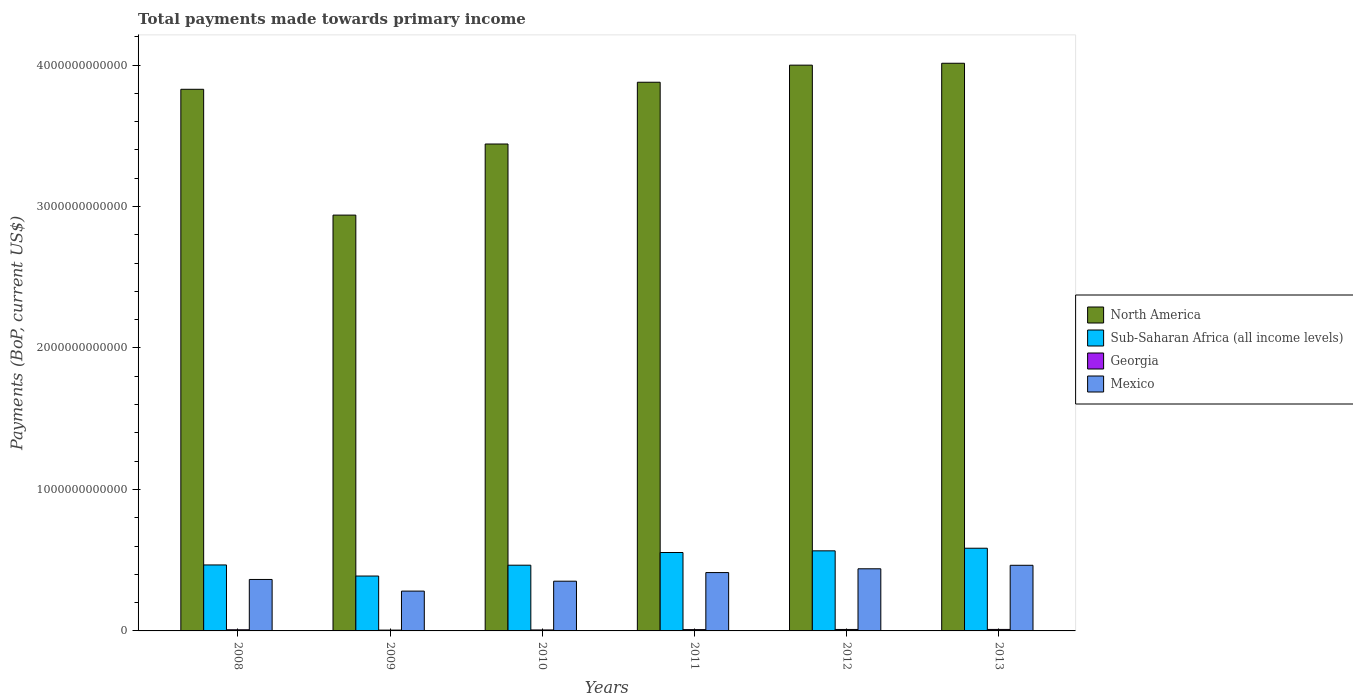How many different coloured bars are there?
Give a very brief answer. 4. Are the number of bars on each tick of the X-axis equal?
Keep it short and to the point. Yes. What is the label of the 4th group of bars from the left?
Make the answer very short. 2011. In how many cases, is the number of bars for a given year not equal to the number of legend labels?
Offer a very short reply. 0. What is the total payments made towards primary income in Mexico in 2013?
Give a very brief answer. 4.64e+11. Across all years, what is the maximum total payments made towards primary income in Mexico?
Your answer should be compact. 4.64e+11. Across all years, what is the minimum total payments made towards primary income in Georgia?
Offer a terse response. 5.78e+09. What is the total total payments made towards primary income in Georgia in the graph?
Your response must be concise. 5.08e+1. What is the difference between the total payments made towards primary income in Georgia in 2010 and that in 2013?
Your answer should be compact. -3.60e+09. What is the difference between the total payments made towards primary income in Georgia in 2011 and the total payments made towards primary income in North America in 2012?
Provide a short and direct response. -3.99e+12. What is the average total payments made towards primary income in Mexico per year?
Keep it short and to the point. 3.85e+11. In the year 2008, what is the difference between the total payments made towards primary income in Sub-Saharan Africa (all income levels) and total payments made towards primary income in Georgia?
Keep it short and to the point. 4.58e+11. In how many years, is the total payments made towards primary income in Sub-Saharan Africa (all income levels) greater than 1200000000000 US$?
Your answer should be compact. 0. What is the ratio of the total payments made towards primary income in North America in 2009 to that in 2012?
Your response must be concise. 0.73. What is the difference between the highest and the second highest total payments made towards primary income in Georgia?
Make the answer very short. 1.32e+08. What is the difference between the highest and the lowest total payments made towards primary income in Georgia?
Your response must be concise. 4.71e+09. Is the sum of the total payments made towards primary income in Sub-Saharan Africa (all income levels) in 2011 and 2013 greater than the maximum total payments made towards primary income in Georgia across all years?
Your response must be concise. Yes. What does the 1st bar from the left in 2013 represents?
Provide a succinct answer. North America. What does the 2nd bar from the right in 2009 represents?
Give a very brief answer. Georgia. How many bars are there?
Offer a terse response. 24. Are all the bars in the graph horizontal?
Give a very brief answer. No. How many years are there in the graph?
Keep it short and to the point. 6. What is the difference between two consecutive major ticks on the Y-axis?
Offer a very short reply. 1.00e+12. Are the values on the major ticks of Y-axis written in scientific E-notation?
Give a very brief answer. No. Where does the legend appear in the graph?
Provide a short and direct response. Center right. How many legend labels are there?
Offer a very short reply. 4. How are the legend labels stacked?
Offer a very short reply. Vertical. What is the title of the graph?
Your answer should be compact. Total payments made towards primary income. What is the label or title of the Y-axis?
Give a very brief answer. Payments (BoP, current US$). What is the Payments (BoP, current US$) of North America in 2008?
Ensure brevity in your answer.  3.83e+12. What is the Payments (BoP, current US$) of Sub-Saharan Africa (all income levels) in 2008?
Your response must be concise. 4.66e+11. What is the Payments (BoP, current US$) of Georgia in 2008?
Provide a short and direct response. 8.11e+09. What is the Payments (BoP, current US$) of Mexico in 2008?
Provide a short and direct response. 3.64e+11. What is the Payments (BoP, current US$) of North America in 2009?
Offer a very short reply. 2.94e+12. What is the Payments (BoP, current US$) of Sub-Saharan Africa (all income levels) in 2009?
Your answer should be compact. 3.88e+11. What is the Payments (BoP, current US$) of Georgia in 2009?
Offer a terse response. 5.78e+09. What is the Payments (BoP, current US$) of Mexico in 2009?
Offer a terse response. 2.82e+11. What is the Payments (BoP, current US$) in North America in 2010?
Your answer should be very brief. 3.44e+12. What is the Payments (BoP, current US$) in Sub-Saharan Africa (all income levels) in 2010?
Your answer should be very brief. 4.65e+11. What is the Payments (BoP, current US$) in Georgia in 2010?
Ensure brevity in your answer.  6.89e+09. What is the Payments (BoP, current US$) of Mexico in 2010?
Offer a very short reply. 3.51e+11. What is the Payments (BoP, current US$) in North America in 2011?
Your response must be concise. 3.88e+12. What is the Payments (BoP, current US$) of Sub-Saharan Africa (all income levels) in 2011?
Give a very brief answer. 5.54e+11. What is the Payments (BoP, current US$) in Georgia in 2011?
Ensure brevity in your answer.  9.17e+09. What is the Payments (BoP, current US$) in Mexico in 2011?
Provide a succinct answer. 4.12e+11. What is the Payments (BoP, current US$) in North America in 2012?
Give a very brief answer. 4.00e+12. What is the Payments (BoP, current US$) of Sub-Saharan Africa (all income levels) in 2012?
Ensure brevity in your answer.  5.66e+11. What is the Payments (BoP, current US$) of Georgia in 2012?
Offer a terse response. 1.04e+1. What is the Payments (BoP, current US$) of Mexico in 2012?
Your response must be concise. 4.39e+11. What is the Payments (BoP, current US$) in North America in 2013?
Your answer should be compact. 4.01e+12. What is the Payments (BoP, current US$) of Sub-Saharan Africa (all income levels) in 2013?
Provide a short and direct response. 5.84e+11. What is the Payments (BoP, current US$) of Georgia in 2013?
Provide a succinct answer. 1.05e+1. What is the Payments (BoP, current US$) of Mexico in 2013?
Your response must be concise. 4.64e+11. Across all years, what is the maximum Payments (BoP, current US$) of North America?
Keep it short and to the point. 4.01e+12. Across all years, what is the maximum Payments (BoP, current US$) of Sub-Saharan Africa (all income levels)?
Provide a short and direct response. 5.84e+11. Across all years, what is the maximum Payments (BoP, current US$) in Georgia?
Give a very brief answer. 1.05e+1. Across all years, what is the maximum Payments (BoP, current US$) in Mexico?
Provide a succinct answer. 4.64e+11. Across all years, what is the minimum Payments (BoP, current US$) in North America?
Your answer should be very brief. 2.94e+12. Across all years, what is the minimum Payments (BoP, current US$) in Sub-Saharan Africa (all income levels)?
Offer a terse response. 3.88e+11. Across all years, what is the minimum Payments (BoP, current US$) of Georgia?
Offer a very short reply. 5.78e+09. Across all years, what is the minimum Payments (BoP, current US$) of Mexico?
Your answer should be compact. 2.82e+11. What is the total Payments (BoP, current US$) in North America in the graph?
Keep it short and to the point. 2.21e+13. What is the total Payments (BoP, current US$) of Sub-Saharan Africa (all income levels) in the graph?
Provide a succinct answer. 3.02e+12. What is the total Payments (BoP, current US$) in Georgia in the graph?
Make the answer very short. 5.08e+1. What is the total Payments (BoP, current US$) in Mexico in the graph?
Make the answer very short. 2.31e+12. What is the difference between the Payments (BoP, current US$) of North America in 2008 and that in 2009?
Your answer should be compact. 8.89e+11. What is the difference between the Payments (BoP, current US$) in Sub-Saharan Africa (all income levels) in 2008 and that in 2009?
Keep it short and to the point. 7.84e+1. What is the difference between the Payments (BoP, current US$) in Georgia in 2008 and that in 2009?
Make the answer very short. 2.34e+09. What is the difference between the Payments (BoP, current US$) of Mexico in 2008 and that in 2009?
Keep it short and to the point. 8.22e+1. What is the difference between the Payments (BoP, current US$) of North America in 2008 and that in 2010?
Offer a very short reply. 3.87e+11. What is the difference between the Payments (BoP, current US$) of Sub-Saharan Africa (all income levels) in 2008 and that in 2010?
Your answer should be compact. 1.75e+09. What is the difference between the Payments (BoP, current US$) of Georgia in 2008 and that in 2010?
Provide a succinct answer. 1.23e+09. What is the difference between the Payments (BoP, current US$) of Mexico in 2008 and that in 2010?
Ensure brevity in your answer.  1.23e+1. What is the difference between the Payments (BoP, current US$) of North America in 2008 and that in 2011?
Make the answer very short. -4.97e+1. What is the difference between the Payments (BoP, current US$) of Sub-Saharan Africa (all income levels) in 2008 and that in 2011?
Offer a very short reply. -8.79e+1. What is the difference between the Payments (BoP, current US$) in Georgia in 2008 and that in 2011?
Keep it short and to the point. -1.05e+09. What is the difference between the Payments (BoP, current US$) in Mexico in 2008 and that in 2011?
Provide a short and direct response. -4.87e+1. What is the difference between the Payments (BoP, current US$) in North America in 2008 and that in 2012?
Keep it short and to the point. -1.71e+11. What is the difference between the Payments (BoP, current US$) in Sub-Saharan Africa (all income levels) in 2008 and that in 2012?
Your answer should be compact. -9.98e+1. What is the difference between the Payments (BoP, current US$) of Georgia in 2008 and that in 2012?
Provide a short and direct response. -2.24e+09. What is the difference between the Payments (BoP, current US$) in Mexico in 2008 and that in 2012?
Provide a short and direct response. -7.54e+1. What is the difference between the Payments (BoP, current US$) in North America in 2008 and that in 2013?
Offer a very short reply. -1.84e+11. What is the difference between the Payments (BoP, current US$) of Sub-Saharan Africa (all income levels) in 2008 and that in 2013?
Your answer should be compact. -1.18e+11. What is the difference between the Payments (BoP, current US$) of Georgia in 2008 and that in 2013?
Your answer should be compact. -2.37e+09. What is the difference between the Payments (BoP, current US$) in Mexico in 2008 and that in 2013?
Make the answer very short. -1.00e+11. What is the difference between the Payments (BoP, current US$) in North America in 2009 and that in 2010?
Make the answer very short. -5.02e+11. What is the difference between the Payments (BoP, current US$) of Sub-Saharan Africa (all income levels) in 2009 and that in 2010?
Your answer should be compact. -7.67e+1. What is the difference between the Payments (BoP, current US$) of Georgia in 2009 and that in 2010?
Offer a terse response. -1.11e+09. What is the difference between the Payments (BoP, current US$) of Mexico in 2009 and that in 2010?
Make the answer very short. -7.00e+1. What is the difference between the Payments (BoP, current US$) in North America in 2009 and that in 2011?
Your response must be concise. -9.39e+11. What is the difference between the Payments (BoP, current US$) in Sub-Saharan Africa (all income levels) in 2009 and that in 2011?
Offer a terse response. -1.66e+11. What is the difference between the Payments (BoP, current US$) of Georgia in 2009 and that in 2011?
Offer a very short reply. -3.39e+09. What is the difference between the Payments (BoP, current US$) of Mexico in 2009 and that in 2011?
Your answer should be compact. -1.31e+11. What is the difference between the Payments (BoP, current US$) in North America in 2009 and that in 2012?
Make the answer very short. -1.06e+12. What is the difference between the Payments (BoP, current US$) of Sub-Saharan Africa (all income levels) in 2009 and that in 2012?
Your answer should be compact. -1.78e+11. What is the difference between the Payments (BoP, current US$) of Georgia in 2009 and that in 2012?
Offer a very short reply. -4.58e+09. What is the difference between the Payments (BoP, current US$) of Mexico in 2009 and that in 2012?
Offer a terse response. -1.58e+11. What is the difference between the Payments (BoP, current US$) of North America in 2009 and that in 2013?
Provide a succinct answer. -1.07e+12. What is the difference between the Payments (BoP, current US$) in Sub-Saharan Africa (all income levels) in 2009 and that in 2013?
Provide a succinct answer. -1.97e+11. What is the difference between the Payments (BoP, current US$) in Georgia in 2009 and that in 2013?
Your answer should be compact. -4.71e+09. What is the difference between the Payments (BoP, current US$) of Mexico in 2009 and that in 2013?
Keep it short and to the point. -1.82e+11. What is the difference between the Payments (BoP, current US$) of North America in 2010 and that in 2011?
Make the answer very short. -4.37e+11. What is the difference between the Payments (BoP, current US$) in Sub-Saharan Africa (all income levels) in 2010 and that in 2011?
Your answer should be very brief. -8.97e+1. What is the difference between the Payments (BoP, current US$) of Georgia in 2010 and that in 2011?
Your response must be concise. -2.28e+09. What is the difference between the Payments (BoP, current US$) in Mexico in 2010 and that in 2011?
Ensure brevity in your answer.  -6.10e+1. What is the difference between the Payments (BoP, current US$) of North America in 2010 and that in 2012?
Your answer should be compact. -5.57e+11. What is the difference between the Payments (BoP, current US$) in Sub-Saharan Africa (all income levels) in 2010 and that in 2012?
Make the answer very short. -1.02e+11. What is the difference between the Payments (BoP, current US$) in Georgia in 2010 and that in 2012?
Give a very brief answer. -3.47e+09. What is the difference between the Payments (BoP, current US$) of Mexico in 2010 and that in 2012?
Your answer should be very brief. -8.77e+1. What is the difference between the Payments (BoP, current US$) of North America in 2010 and that in 2013?
Ensure brevity in your answer.  -5.71e+11. What is the difference between the Payments (BoP, current US$) of Sub-Saharan Africa (all income levels) in 2010 and that in 2013?
Your answer should be very brief. -1.20e+11. What is the difference between the Payments (BoP, current US$) in Georgia in 2010 and that in 2013?
Your response must be concise. -3.60e+09. What is the difference between the Payments (BoP, current US$) in Mexico in 2010 and that in 2013?
Your answer should be very brief. -1.12e+11. What is the difference between the Payments (BoP, current US$) in North America in 2011 and that in 2012?
Your answer should be compact. -1.21e+11. What is the difference between the Payments (BoP, current US$) of Sub-Saharan Africa (all income levels) in 2011 and that in 2012?
Your response must be concise. -1.19e+1. What is the difference between the Payments (BoP, current US$) in Georgia in 2011 and that in 2012?
Provide a succinct answer. -1.19e+09. What is the difference between the Payments (BoP, current US$) in Mexico in 2011 and that in 2012?
Give a very brief answer. -2.67e+1. What is the difference between the Payments (BoP, current US$) in North America in 2011 and that in 2013?
Give a very brief answer. -1.34e+11. What is the difference between the Payments (BoP, current US$) in Sub-Saharan Africa (all income levels) in 2011 and that in 2013?
Make the answer very short. -3.03e+1. What is the difference between the Payments (BoP, current US$) of Georgia in 2011 and that in 2013?
Your response must be concise. -1.32e+09. What is the difference between the Payments (BoP, current US$) in Mexico in 2011 and that in 2013?
Your response must be concise. -5.14e+1. What is the difference between the Payments (BoP, current US$) of North America in 2012 and that in 2013?
Your answer should be compact. -1.33e+1. What is the difference between the Payments (BoP, current US$) in Sub-Saharan Africa (all income levels) in 2012 and that in 2013?
Your answer should be very brief. -1.84e+1. What is the difference between the Payments (BoP, current US$) of Georgia in 2012 and that in 2013?
Keep it short and to the point. -1.32e+08. What is the difference between the Payments (BoP, current US$) in Mexico in 2012 and that in 2013?
Your answer should be very brief. -2.47e+1. What is the difference between the Payments (BoP, current US$) of North America in 2008 and the Payments (BoP, current US$) of Sub-Saharan Africa (all income levels) in 2009?
Make the answer very short. 3.44e+12. What is the difference between the Payments (BoP, current US$) in North America in 2008 and the Payments (BoP, current US$) in Georgia in 2009?
Provide a succinct answer. 3.82e+12. What is the difference between the Payments (BoP, current US$) of North America in 2008 and the Payments (BoP, current US$) of Mexico in 2009?
Offer a very short reply. 3.55e+12. What is the difference between the Payments (BoP, current US$) of Sub-Saharan Africa (all income levels) in 2008 and the Payments (BoP, current US$) of Georgia in 2009?
Your answer should be compact. 4.61e+11. What is the difference between the Payments (BoP, current US$) of Sub-Saharan Africa (all income levels) in 2008 and the Payments (BoP, current US$) of Mexico in 2009?
Provide a succinct answer. 1.85e+11. What is the difference between the Payments (BoP, current US$) in Georgia in 2008 and the Payments (BoP, current US$) in Mexico in 2009?
Offer a terse response. -2.73e+11. What is the difference between the Payments (BoP, current US$) of North America in 2008 and the Payments (BoP, current US$) of Sub-Saharan Africa (all income levels) in 2010?
Offer a very short reply. 3.36e+12. What is the difference between the Payments (BoP, current US$) of North America in 2008 and the Payments (BoP, current US$) of Georgia in 2010?
Provide a succinct answer. 3.82e+12. What is the difference between the Payments (BoP, current US$) in North America in 2008 and the Payments (BoP, current US$) in Mexico in 2010?
Offer a terse response. 3.48e+12. What is the difference between the Payments (BoP, current US$) in Sub-Saharan Africa (all income levels) in 2008 and the Payments (BoP, current US$) in Georgia in 2010?
Ensure brevity in your answer.  4.59e+11. What is the difference between the Payments (BoP, current US$) in Sub-Saharan Africa (all income levels) in 2008 and the Payments (BoP, current US$) in Mexico in 2010?
Offer a very short reply. 1.15e+11. What is the difference between the Payments (BoP, current US$) in Georgia in 2008 and the Payments (BoP, current US$) in Mexico in 2010?
Ensure brevity in your answer.  -3.43e+11. What is the difference between the Payments (BoP, current US$) in North America in 2008 and the Payments (BoP, current US$) in Sub-Saharan Africa (all income levels) in 2011?
Your response must be concise. 3.27e+12. What is the difference between the Payments (BoP, current US$) in North America in 2008 and the Payments (BoP, current US$) in Georgia in 2011?
Your response must be concise. 3.82e+12. What is the difference between the Payments (BoP, current US$) in North America in 2008 and the Payments (BoP, current US$) in Mexico in 2011?
Your answer should be compact. 3.42e+12. What is the difference between the Payments (BoP, current US$) in Sub-Saharan Africa (all income levels) in 2008 and the Payments (BoP, current US$) in Georgia in 2011?
Your response must be concise. 4.57e+11. What is the difference between the Payments (BoP, current US$) of Sub-Saharan Africa (all income levels) in 2008 and the Payments (BoP, current US$) of Mexico in 2011?
Provide a succinct answer. 5.39e+1. What is the difference between the Payments (BoP, current US$) in Georgia in 2008 and the Payments (BoP, current US$) in Mexico in 2011?
Give a very brief answer. -4.04e+11. What is the difference between the Payments (BoP, current US$) of North America in 2008 and the Payments (BoP, current US$) of Sub-Saharan Africa (all income levels) in 2012?
Make the answer very short. 3.26e+12. What is the difference between the Payments (BoP, current US$) in North America in 2008 and the Payments (BoP, current US$) in Georgia in 2012?
Your response must be concise. 3.82e+12. What is the difference between the Payments (BoP, current US$) in North America in 2008 and the Payments (BoP, current US$) in Mexico in 2012?
Provide a succinct answer. 3.39e+12. What is the difference between the Payments (BoP, current US$) of Sub-Saharan Africa (all income levels) in 2008 and the Payments (BoP, current US$) of Georgia in 2012?
Give a very brief answer. 4.56e+11. What is the difference between the Payments (BoP, current US$) in Sub-Saharan Africa (all income levels) in 2008 and the Payments (BoP, current US$) in Mexico in 2012?
Keep it short and to the point. 2.71e+1. What is the difference between the Payments (BoP, current US$) of Georgia in 2008 and the Payments (BoP, current US$) of Mexico in 2012?
Provide a succinct answer. -4.31e+11. What is the difference between the Payments (BoP, current US$) in North America in 2008 and the Payments (BoP, current US$) in Sub-Saharan Africa (all income levels) in 2013?
Ensure brevity in your answer.  3.24e+12. What is the difference between the Payments (BoP, current US$) of North America in 2008 and the Payments (BoP, current US$) of Georgia in 2013?
Keep it short and to the point. 3.82e+12. What is the difference between the Payments (BoP, current US$) of North America in 2008 and the Payments (BoP, current US$) of Mexico in 2013?
Provide a short and direct response. 3.36e+12. What is the difference between the Payments (BoP, current US$) in Sub-Saharan Africa (all income levels) in 2008 and the Payments (BoP, current US$) in Georgia in 2013?
Your answer should be compact. 4.56e+11. What is the difference between the Payments (BoP, current US$) of Sub-Saharan Africa (all income levels) in 2008 and the Payments (BoP, current US$) of Mexico in 2013?
Provide a short and direct response. 2.45e+09. What is the difference between the Payments (BoP, current US$) in Georgia in 2008 and the Payments (BoP, current US$) in Mexico in 2013?
Make the answer very short. -4.56e+11. What is the difference between the Payments (BoP, current US$) of North America in 2009 and the Payments (BoP, current US$) of Sub-Saharan Africa (all income levels) in 2010?
Ensure brevity in your answer.  2.47e+12. What is the difference between the Payments (BoP, current US$) of North America in 2009 and the Payments (BoP, current US$) of Georgia in 2010?
Provide a short and direct response. 2.93e+12. What is the difference between the Payments (BoP, current US$) in North America in 2009 and the Payments (BoP, current US$) in Mexico in 2010?
Your answer should be very brief. 2.59e+12. What is the difference between the Payments (BoP, current US$) of Sub-Saharan Africa (all income levels) in 2009 and the Payments (BoP, current US$) of Georgia in 2010?
Give a very brief answer. 3.81e+11. What is the difference between the Payments (BoP, current US$) in Sub-Saharan Africa (all income levels) in 2009 and the Payments (BoP, current US$) in Mexico in 2010?
Your answer should be compact. 3.64e+1. What is the difference between the Payments (BoP, current US$) in Georgia in 2009 and the Payments (BoP, current US$) in Mexico in 2010?
Make the answer very short. -3.46e+11. What is the difference between the Payments (BoP, current US$) in North America in 2009 and the Payments (BoP, current US$) in Sub-Saharan Africa (all income levels) in 2011?
Your answer should be compact. 2.38e+12. What is the difference between the Payments (BoP, current US$) of North America in 2009 and the Payments (BoP, current US$) of Georgia in 2011?
Your response must be concise. 2.93e+12. What is the difference between the Payments (BoP, current US$) in North America in 2009 and the Payments (BoP, current US$) in Mexico in 2011?
Keep it short and to the point. 2.53e+12. What is the difference between the Payments (BoP, current US$) in Sub-Saharan Africa (all income levels) in 2009 and the Payments (BoP, current US$) in Georgia in 2011?
Your response must be concise. 3.79e+11. What is the difference between the Payments (BoP, current US$) in Sub-Saharan Africa (all income levels) in 2009 and the Payments (BoP, current US$) in Mexico in 2011?
Offer a very short reply. -2.46e+1. What is the difference between the Payments (BoP, current US$) of Georgia in 2009 and the Payments (BoP, current US$) of Mexico in 2011?
Keep it short and to the point. -4.07e+11. What is the difference between the Payments (BoP, current US$) in North America in 2009 and the Payments (BoP, current US$) in Sub-Saharan Africa (all income levels) in 2012?
Your answer should be very brief. 2.37e+12. What is the difference between the Payments (BoP, current US$) in North America in 2009 and the Payments (BoP, current US$) in Georgia in 2012?
Your answer should be very brief. 2.93e+12. What is the difference between the Payments (BoP, current US$) of North America in 2009 and the Payments (BoP, current US$) of Mexico in 2012?
Keep it short and to the point. 2.50e+12. What is the difference between the Payments (BoP, current US$) of Sub-Saharan Africa (all income levels) in 2009 and the Payments (BoP, current US$) of Georgia in 2012?
Keep it short and to the point. 3.78e+11. What is the difference between the Payments (BoP, current US$) in Sub-Saharan Africa (all income levels) in 2009 and the Payments (BoP, current US$) in Mexico in 2012?
Your answer should be compact. -5.13e+1. What is the difference between the Payments (BoP, current US$) of Georgia in 2009 and the Payments (BoP, current US$) of Mexico in 2012?
Ensure brevity in your answer.  -4.33e+11. What is the difference between the Payments (BoP, current US$) of North America in 2009 and the Payments (BoP, current US$) of Sub-Saharan Africa (all income levels) in 2013?
Provide a short and direct response. 2.35e+12. What is the difference between the Payments (BoP, current US$) of North America in 2009 and the Payments (BoP, current US$) of Georgia in 2013?
Your response must be concise. 2.93e+12. What is the difference between the Payments (BoP, current US$) of North America in 2009 and the Payments (BoP, current US$) of Mexico in 2013?
Provide a short and direct response. 2.48e+12. What is the difference between the Payments (BoP, current US$) in Sub-Saharan Africa (all income levels) in 2009 and the Payments (BoP, current US$) in Georgia in 2013?
Ensure brevity in your answer.  3.77e+11. What is the difference between the Payments (BoP, current US$) of Sub-Saharan Africa (all income levels) in 2009 and the Payments (BoP, current US$) of Mexico in 2013?
Your answer should be compact. -7.60e+1. What is the difference between the Payments (BoP, current US$) of Georgia in 2009 and the Payments (BoP, current US$) of Mexico in 2013?
Make the answer very short. -4.58e+11. What is the difference between the Payments (BoP, current US$) in North America in 2010 and the Payments (BoP, current US$) in Sub-Saharan Africa (all income levels) in 2011?
Keep it short and to the point. 2.89e+12. What is the difference between the Payments (BoP, current US$) of North America in 2010 and the Payments (BoP, current US$) of Georgia in 2011?
Your answer should be very brief. 3.43e+12. What is the difference between the Payments (BoP, current US$) of North America in 2010 and the Payments (BoP, current US$) of Mexico in 2011?
Your answer should be compact. 3.03e+12. What is the difference between the Payments (BoP, current US$) in Sub-Saharan Africa (all income levels) in 2010 and the Payments (BoP, current US$) in Georgia in 2011?
Your response must be concise. 4.55e+11. What is the difference between the Payments (BoP, current US$) in Sub-Saharan Africa (all income levels) in 2010 and the Payments (BoP, current US$) in Mexico in 2011?
Your answer should be very brief. 5.21e+1. What is the difference between the Payments (BoP, current US$) in Georgia in 2010 and the Payments (BoP, current US$) in Mexico in 2011?
Provide a succinct answer. -4.06e+11. What is the difference between the Payments (BoP, current US$) in North America in 2010 and the Payments (BoP, current US$) in Sub-Saharan Africa (all income levels) in 2012?
Give a very brief answer. 2.88e+12. What is the difference between the Payments (BoP, current US$) of North America in 2010 and the Payments (BoP, current US$) of Georgia in 2012?
Ensure brevity in your answer.  3.43e+12. What is the difference between the Payments (BoP, current US$) in North America in 2010 and the Payments (BoP, current US$) in Mexico in 2012?
Keep it short and to the point. 3.00e+12. What is the difference between the Payments (BoP, current US$) of Sub-Saharan Africa (all income levels) in 2010 and the Payments (BoP, current US$) of Georgia in 2012?
Keep it short and to the point. 4.54e+11. What is the difference between the Payments (BoP, current US$) of Sub-Saharan Africa (all income levels) in 2010 and the Payments (BoP, current US$) of Mexico in 2012?
Your response must be concise. 2.54e+1. What is the difference between the Payments (BoP, current US$) in Georgia in 2010 and the Payments (BoP, current US$) in Mexico in 2012?
Offer a terse response. -4.32e+11. What is the difference between the Payments (BoP, current US$) in North America in 2010 and the Payments (BoP, current US$) in Sub-Saharan Africa (all income levels) in 2013?
Your answer should be compact. 2.86e+12. What is the difference between the Payments (BoP, current US$) in North America in 2010 and the Payments (BoP, current US$) in Georgia in 2013?
Provide a succinct answer. 3.43e+12. What is the difference between the Payments (BoP, current US$) in North America in 2010 and the Payments (BoP, current US$) in Mexico in 2013?
Make the answer very short. 2.98e+12. What is the difference between the Payments (BoP, current US$) in Sub-Saharan Africa (all income levels) in 2010 and the Payments (BoP, current US$) in Georgia in 2013?
Offer a terse response. 4.54e+11. What is the difference between the Payments (BoP, current US$) of Sub-Saharan Africa (all income levels) in 2010 and the Payments (BoP, current US$) of Mexico in 2013?
Your answer should be compact. 6.98e+08. What is the difference between the Payments (BoP, current US$) of Georgia in 2010 and the Payments (BoP, current US$) of Mexico in 2013?
Give a very brief answer. -4.57e+11. What is the difference between the Payments (BoP, current US$) in North America in 2011 and the Payments (BoP, current US$) in Sub-Saharan Africa (all income levels) in 2012?
Provide a short and direct response. 3.31e+12. What is the difference between the Payments (BoP, current US$) in North America in 2011 and the Payments (BoP, current US$) in Georgia in 2012?
Offer a terse response. 3.87e+12. What is the difference between the Payments (BoP, current US$) in North America in 2011 and the Payments (BoP, current US$) in Mexico in 2012?
Keep it short and to the point. 3.44e+12. What is the difference between the Payments (BoP, current US$) in Sub-Saharan Africa (all income levels) in 2011 and the Payments (BoP, current US$) in Georgia in 2012?
Your answer should be very brief. 5.44e+11. What is the difference between the Payments (BoP, current US$) in Sub-Saharan Africa (all income levels) in 2011 and the Payments (BoP, current US$) in Mexico in 2012?
Provide a short and direct response. 1.15e+11. What is the difference between the Payments (BoP, current US$) of Georgia in 2011 and the Payments (BoP, current US$) of Mexico in 2012?
Provide a succinct answer. -4.30e+11. What is the difference between the Payments (BoP, current US$) of North America in 2011 and the Payments (BoP, current US$) of Sub-Saharan Africa (all income levels) in 2013?
Offer a very short reply. 3.29e+12. What is the difference between the Payments (BoP, current US$) of North America in 2011 and the Payments (BoP, current US$) of Georgia in 2013?
Offer a terse response. 3.87e+12. What is the difference between the Payments (BoP, current US$) of North America in 2011 and the Payments (BoP, current US$) of Mexico in 2013?
Provide a succinct answer. 3.41e+12. What is the difference between the Payments (BoP, current US$) of Sub-Saharan Africa (all income levels) in 2011 and the Payments (BoP, current US$) of Georgia in 2013?
Offer a terse response. 5.44e+11. What is the difference between the Payments (BoP, current US$) in Sub-Saharan Africa (all income levels) in 2011 and the Payments (BoP, current US$) in Mexico in 2013?
Provide a short and direct response. 9.04e+1. What is the difference between the Payments (BoP, current US$) in Georgia in 2011 and the Payments (BoP, current US$) in Mexico in 2013?
Ensure brevity in your answer.  -4.55e+11. What is the difference between the Payments (BoP, current US$) in North America in 2012 and the Payments (BoP, current US$) in Sub-Saharan Africa (all income levels) in 2013?
Give a very brief answer. 3.41e+12. What is the difference between the Payments (BoP, current US$) in North America in 2012 and the Payments (BoP, current US$) in Georgia in 2013?
Make the answer very short. 3.99e+12. What is the difference between the Payments (BoP, current US$) in North America in 2012 and the Payments (BoP, current US$) in Mexico in 2013?
Ensure brevity in your answer.  3.54e+12. What is the difference between the Payments (BoP, current US$) in Sub-Saharan Africa (all income levels) in 2012 and the Payments (BoP, current US$) in Georgia in 2013?
Ensure brevity in your answer.  5.56e+11. What is the difference between the Payments (BoP, current US$) in Sub-Saharan Africa (all income levels) in 2012 and the Payments (BoP, current US$) in Mexico in 2013?
Offer a very short reply. 1.02e+11. What is the difference between the Payments (BoP, current US$) in Georgia in 2012 and the Payments (BoP, current US$) in Mexico in 2013?
Provide a succinct answer. -4.53e+11. What is the average Payments (BoP, current US$) of North America per year?
Give a very brief answer. 3.68e+12. What is the average Payments (BoP, current US$) of Sub-Saharan Africa (all income levels) per year?
Offer a terse response. 5.04e+11. What is the average Payments (BoP, current US$) in Georgia per year?
Keep it short and to the point. 8.47e+09. What is the average Payments (BoP, current US$) in Mexico per year?
Give a very brief answer. 3.85e+11. In the year 2008, what is the difference between the Payments (BoP, current US$) of North America and Payments (BoP, current US$) of Sub-Saharan Africa (all income levels)?
Provide a succinct answer. 3.36e+12. In the year 2008, what is the difference between the Payments (BoP, current US$) in North America and Payments (BoP, current US$) in Georgia?
Your answer should be compact. 3.82e+12. In the year 2008, what is the difference between the Payments (BoP, current US$) of North America and Payments (BoP, current US$) of Mexico?
Offer a very short reply. 3.46e+12. In the year 2008, what is the difference between the Payments (BoP, current US$) of Sub-Saharan Africa (all income levels) and Payments (BoP, current US$) of Georgia?
Your answer should be very brief. 4.58e+11. In the year 2008, what is the difference between the Payments (BoP, current US$) of Sub-Saharan Africa (all income levels) and Payments (BoP, current US$) of Mexico?
Give a very brief answer. 1.03e+11. In the year 2008, what is the difference between the Payments (BoP, current US$) in Georgia and Payments (BoP, current US$) in Mexico?
Give a very brief answer. -3.56e+11. In the year 2009, what is the difference between the Payments (BoP, current US$) of North America and Payments (BoP, current US$) of Sub-Saharan Africa (all income levels)?
Provide a succinct answer. 2.55e+12. In the year 2009, what is the difference between the Payments (BoP, current US$) in North America and Payments (BoP, current US$) in Georgia?
Give a very brief answer. 2.93e+12. In the year 2009, what is the difference between the Payments (BoP, current US$) of North America and Payments (BoP, current US$) of Mexico?
Keep it short and to the point. 2.66e+12. In the year 2009, what is the difference between the Payments (BoP, current US$) in Sub-Saharan Africa (all income levels) and Payments (BoP, current US$) in Georgia?
Keep it short and to the point. 3.82e+11. In the year 2009, what is the difference between the Payments (BoP, current US$) of Sub-Saharan Africa (all income levels) and Payments (BoP, current US$) of Mexico?
Your answer should be very brief. 1.06e+11. In the year 2009, what is the difference between the Payments (BoP, current US$) in Georgia and Payments (BoP, current US$) in Mexico?
Offer a very short reply. -2.76e+11. In the year 2010, what is the difference between the Payments (BoP, current US$) of North America and Payments (BoP, current US$) of Sub-Saharan Africa (all income levels)?
Offer a very short reply. 2.98e+12. In the year 2010, what is the difference between the Payments (BoP, current US$) of North America and Payments (BoP, current US$) of Georgia?
Make the answer very short. 3.43e+12. In the year 2010, what is the difference between the Payments (BoP, current US$) of North America and Payments (BoP, current US$) of Mexico?
Your answer should be very brief. 3.09e+12. In the year 2010, what is the difference between the Payments (BoP, current US$) of Sub-Saharan Africa (all income levels) and Payments (BoP, current US$) of Georgia?
Offer a terse response. 4.58e+11. In the year 2010, what is the difference between the Payments (BoP, current US$) of Sub-Saharan Africa (all income levels) and Payments (BoP, current US$) of Mexico?
Your answer should be very brief. 1.13e+11. In the year 2010, what is the difference between the Payments (BoP, current US$) in Georgia and Payments (BoP, current US$) in Mexico?
Your response must be concise. -3.45e+11. In the year 2011, what is the difference between the Payments (BoP, current US$) of North America and Payments (BoP, current US$) of Sub-Saharan Africa (all income levels)?
Ensure brevity in your answer.  3.32e+12. In the year 2011, what is the difference between the Payments (BoP, current US$) of North America and Payments (BoP, current US$) of Georgia?
Make the answer very short. 3.87e+12. In the year 2011, what is the difference between the Payments (BoP, current US$) of North America and Payments (BoP, current US$) of Mexico?
Your answer should be very brief. 3.47e+12. In the year 2011, what is the difference between the Payments (BoP, current US$) of Sub-Saharan Africa (all income levels) and Payments (BoP, current US$) of Georgia?
Your answer should be very brief. 5.45e+11. In the year 2011, what is the difference between the Payments (BoP, current US$) in Sub-Saharan Africa (all income levels) and Payments (BoP, current US$) in Mexico?
Keep it short and to the point. 1.42e+11. In the year 2011, what is the difference between the Payments (BoP, current US$) of Georgia and Payments (BoP, current US$) of Mexico?
Your response must be concise. -4.03e+11. In the year 2012, what is the difference between the Payments (BoP, current US$) of North America and Payments (BoP, current US$) of Sub-Saharan Africa (all income levels)?
Offer a terse response. 3.43e+12. In the year 2012, what is the difference between the Payments (BoP, current US$) of North America and Payments (BoP, current US$) of Georgia?
Your answer should be very brief. 3.99e+12. In the year 2012, what is the difference between the Payments (BoP, current US$) of North America and Payments (BoP, current US$) of Mexico?
Provide a short and direct response. 3.56e+12. In the year 2012, what is the difference between the Payments (BoP, current US$) of Sub-Saharan Africa (all income levels) and Payments (BoP, current US$) of Georgia?
Your answer should be compact. 5.56e+11. In the year 2012, what is the difference between the Payments (BoP, current US$) of Sub-Saharan Africa (all income levels) and Payments (BoP, current US$) of Mexico?
Ensure brevity in your answer.  1.27e+11. In the year 2012, what is the difference between the Payments (BoP, current US$) of Georgia and Payments (BoP, current US$) of Mexico?
Make the answer very short. -4.29e+11. In the year 2013, what is the difference between the Payments (BoP, current US$) in North America and Payments (BoP, current US$) in Sub-Saharan Africa (all income levels)?
Your answer should be compact. 3.43e+12. In the year 2013, what is the difference between the Payments (BoP, current US$) in North America and Payments (BoP, current US$) in Georgia?
Provide a short and direct response. 4.00e+12. In the year 2013, what is the difference between the Payments (BoP, current US$) of North America and Payments (BoP, current US$) of Mexico?
Offer a very short reply. 3.55e+12. In the year 2013, what is the difference between the Payments (BoP, current US$) in Sub-Saharan Africa (all income levels) and Payments (BoP, current US$) in Georgia?
Your answer should be very brief. 5.74e+11. In the year 2013, what is the difference between the Payments (BoP, current US$) of Sub-Saharan Africa (all income levels) and Payments (BoP, current US$) of Mexico?
Offer a terse response. 1.21e+11. In the year 2013, what is the difference between the Payments (BoP, current US$) of Georgia and Payments (BoP, current US$) of Mexico?
Keep it short and to the point. -4.53e+11. What is the ratio of the Payments (BoP, current US$) of North America in 2008 to that in 2009?
Your answer should be compact. 1.3. What is the ratio of the Payments (BoP, current US$) in Sub-Saharan Africa (all income levels) in 2008 to that in 2009?
Provide a succinct answer. 1.2. What is the ratio of the Payments (BoP, current US$) in Georgia in 2008 to that in 2009?
Make the answer very short. 1.4. What is the ratio of the Payments (BoP, current US$) in Mexico in 2008 to that in 2009?
Make the answer very short. 1.29. What is the ratio of the Payments (BoP, current US$) of North America in 2008 to that in 2010?
Give a very brief answer. 1.11. What is the ratio of the Payments (BoP, current US$) in Georgia in 2008 to that in 2010?
Your answer should be compact. 1.18. What is the ratio of the Payments (BoP, current US$) in Mexico in 2008 to that in 2010?
Offer a very short reply. 1.03. What is the ratio of the Payments (BoP, current US$) in North America in 2008 to that in 2011?
Provide a succinct answer. 0.99. What is the ratio of the Payments (BoP, current US$) of Sub-Saharan Africa (all income levels) in 2008 to that in 2011?
Keep it short and to the point. 0.84. What is the ratio of the Payments (BoP, current US$) in Georgia in 2008 to that in 2011?
Provide a short and direct response. 0.89. What is the ratio of the Payments (BoP, current US$) in Mexico in 2008 to that in 2011?
Your response must be concise. 0.88. What is the ratio of the Payments (BoP, current US$) in North America in 2008 to that in 2012?
Provide a short and direct response. 0.96. What is the ratio of the Payments (BoP, current US$) of Sub-Saharan Africa (all income levels) in 2008 to that in 2012?
Offer a very short reply. 0.82. What is the ratio of the Payments (BoP, current US$) of Georgia in 2008 to that in 2012?
Give a very brief answer. 0.78. What is the ratio of the Payments (BoP, current US$) of Mexico in 2008 to that in 2012?
Ensure brevity in your answer.  0.83. What is the ratio of the Payments (BoP, current US$) in North America in 2008 to that in 2013?
Make the answer very short. 0.95. What is the ratio of the Payments (BoP, current US$) of Sub-Saharan Africa (all income levels) in 2008 to that in 2013?
Make the answer very short. 0.8. What is the ratio of the Payments (BoP, current US$) in Georgia in 2008 to that in 2013?
Offer a very short reply. 0.77. What is the ratio of the Payments (BoP, current US$) in Mexico in 2008 to that in 2013?
Your answer should be very brief. 0.78. What is the ratio of the Payments (BoP, current US$) of North America in 2009 to that in 2010?
Provide a short and direct response. 0.85. What is the ratio of the Payments (BoP, current US$) in Sub-Saharan Africa (all income levels) in 2009 to that in 2010?
Ensure brevity in your answer.  0.83. What is the ratio of the Payments (BoP, current US$) of Georgia in 2009 to that in 2010?
Provide a succinct answer. 0.84. What is the ratio of the Payments (BoP, current US$) of Mexico in 2009 to that in 2010?
Ensure brevity in your answer.  0.8. What is the ratio of the Payments (BoP, current US$) of North America in 2009 to that in 2011?
Give a very brief answer. 0.76. What is the ratio of the Payments (BoP, current US$) in Sub-Saharan Africa (all income levels) in 2009 to that in 2011?
Your answer should be very brief. 0.7. What is the ratio of the Payments (BoP, current US$) in Georgia in 2009 to that in 2011?
Offer a very short reply. 0.63. What is the ratio of the Payments (BoP, current US$) in Mexico in 2009 to that in 2011?
Make the answer very short. 0.68. What is the ratio of the Payments (BoP, current US$) in North America in 2009 to that in 2012?
Offer a very short reply. 0.73. What is the ratio of the Payments (BoP, current US$) of Sub-Saharan Africa (all income levels) in 2009 to that in 2012?
Make the answer very short. 0.69. What is the ratio of the Payments (BoP, current US$) of Georgia in 2009 to that in 2012?
Offer a very short reply. 0.56. What is the ratio of the Payments (BoP, current US$) in Mexico in 2009 to that in 2012?
Make the answer very short. 0.64. What is the ratio of the Payments (BoP, current US$) in North America in 2009 to that in 2013?
Keep it short and to the point. 0.73. What is the ratio of the Payments (BoP, current US$) of Sub-Saharan Africa (all income levels) in 2009 to that in 2013?
Your response must be concise. 0.66. What is the ratio of the Payments (BoP, current US$) in Georgia in 2009 to that in 2013?
Ensure brevity in your answer.  0.55. What is the ratio of the Payments (BoP, current US$) of Mexico in 2009 to that in 2013?
Make the answer very short. 0.61. What is the ratio of the Payments (BoP, current US$) of North America in 2010 to that in 2011?
Provide a short and direct response. 0.89. What is the ratio of the Payments (BoP, current US$) of Sub-Saharan Africa (all income levels) in 2010 to that in 2011?
Your answer should be very brief. 0.84. What is the ratio of the Payments (BoP, current US$) of Georgia in 2010 to that in 2011?
Your response must be concise. 0.75. What is the ratio of the Payments (BoP, current US$) of Mexico in 2010 to that in 2011?
Your answer should be very brief. 0.85. What is the ratio of the Payments (BoP, current US$) of North America in 2010 to that in 2012?
Your response must be concise. 0.86. What is the ratio of the Payments (BoP, current US$) in Sub-Saharan Africa (all income levels) in 2010 to that in 2012?
Your answer should be very brief. 0.82. What is the ratio of the Payments (BoP, current US$) of Georgia in 2010 to that in 2012?
Give a very brief answer. 0.66. What is the ratio of the Payments (BoP, current US$) in Mexico in 2010 to that in 2012?
Keep it short and to the point. 0.8. What is the ratio of the Payments (BoP, current US$) of North America in 2010 to that in 2013?
Offer a very short reply. 0.86. What is the ratio of the Payments (BoP, current US$) of Sub-Saharan Africa (all income levels) in 2010 to that in 2013?
Offer a terse response. 0.79. What is the ratio of the Payments (BoP, current US$) of Georgia in 2010 to that in 2013?
Keep it short and to the point. 0.66. What is the ratio of the Payments (BoP, current US$) in Mexico in 2010 to that in 2013?
Keep it short and to the point. 0.76. What is the ratio of the Payments (BoP, current US$) in North America in 2011 to that in 2012?
Offer a very short reply. 0.97. What is the ratio of the Payments (BoP, current US$) of Sub-Saharan Africa (all income levels) in 2011 to that in 2012?
Your answer should be very brief. 0.98. What is the ratio of the Payments (BoP, current US$) of Georgia in 2011 to that in 2012?
Your answer should be very brief. 0.89. What is the ratio of the Payments (BoP, current US$) of Mexico in 2011 to that in 2012?
Ensure brevity in your answer.  0.94. What is the ratio of the Payments (BoP, current US$) of North America in 2011 to that in 2013?
Your answer should be very brief. 0.97. What is the ratio of the Payments (BoP, current US$) in Sub-Saharan Africa (all income levels) in 2011 to that in 2013?
Provide a short and direct response. 0.95. What is the ratio of the Payments (BoP, current US$) in Georgia in 2011 to that in 2013?
Give a very brief answer. 0.87. What is the ratio of the Payments (BoP, current US$) of Mexico in 2011 to that in 2013?
Ensure brevity in your answer.  0.89. What is the ratio of the Payments (BoP, current US$) in Sub-Saharan Africa (all income levels) in 2012 to that in 2013?
Give a very brief answer. 0.97. What is the ratio of the Payments (BoP, current US$) of Georgia in 2012 to that in 2013?
Give a very brief answer. 0.99. What is the ratio of the Payments (BoP, current US$) in Mexico in 2012 to that in 2013?
Give a very brief answer. 0.95. What is the difference between the highest and the second highest Payments (BoP, current US$) in North America?
Provide a succinct answer. 1.33e+1. What is the difference between the highest and the second highest Payments (BoP, current US$) of Sub-Saharan Africa (all income levels)?
Keep it short and to the point. 1.84e+1. What is the difference between the highest and the second highest Payments (BoP, current US$) of Georgia?
Keep it short and to the point. 1.32e+08. What is the difference between the highest and the second highest Payments (BoP, current US$) in Mexico?
Provide a short and direct response. 2.47e+1. What is the difference between the highest and the lowest Payments (BoP, current US$) in North America?
Your answer should be very brief. 1.07e+12. What is the difference between the highest and the lowest Payments (BoP, current US$) in Sub-Saharan Africa (all income levels)?
Give a very brief answer. 1.97e+11. What is the difference between the highest and the lowest Payments (BoP, current US$) of Georgia?
Provide a short and direct response. 4.71e+09. What is the difference between the highest and the lowest Payments (BoP, current US$) of Mexico?
Your answer should be very brief. 1.82e+11. 